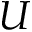<formula> <loc_0><loc_0><loc_500><loc_500>U</formula> 